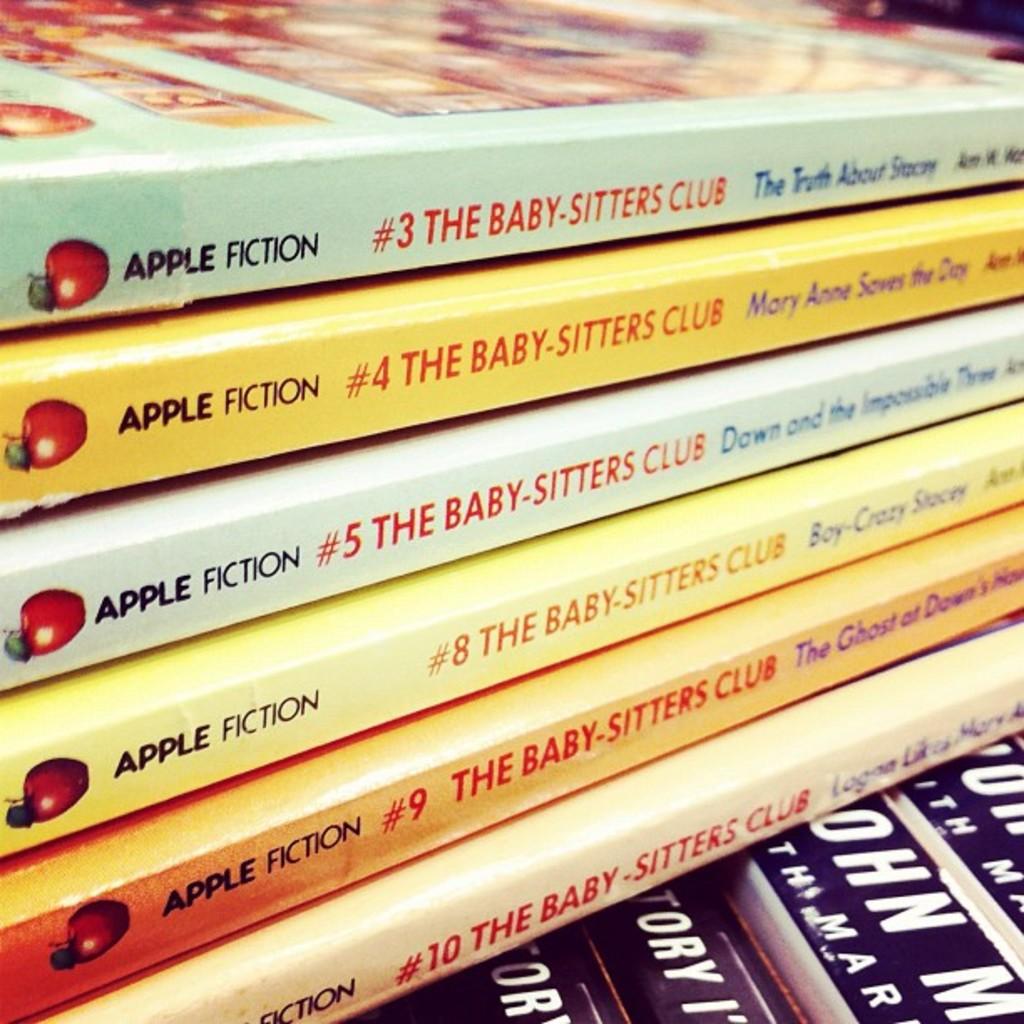What book series is being displayed here?
Offer a very short reply. The baby-sitters club. Who is the publisher of these books?
Your answer should be very brief. Apple fiction. 